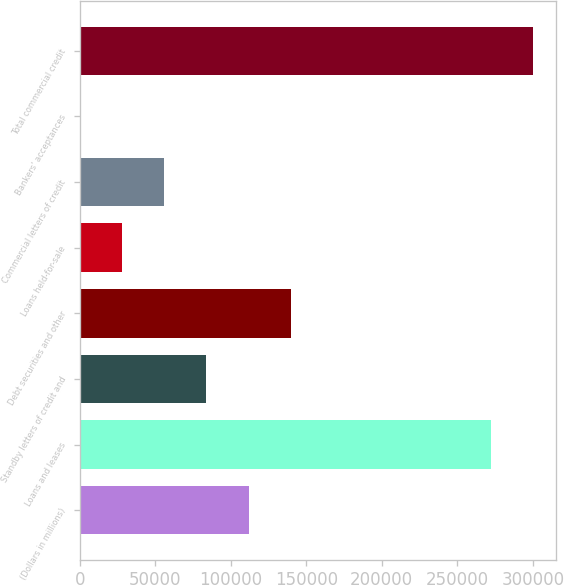Convert chart. <chart><loc_0><loc_0><loc_500><loc_500><bar_chart><fcel>(Dollars in millions)<fcel>Loans and leases<fcel>Standby letters of credit and<fcel>Debt securities and other<fcel>Loans held-for-sale<fcel>Commercial letters of credit<fcel>Bankers' acceptances<fcel>Total commercial credit<nl><fcel>111883<fcel>272172<fcel>83918<fcel>139848<fcel>27988<fcel>55953<fcel>23<fcel>300137<nl></chart> 